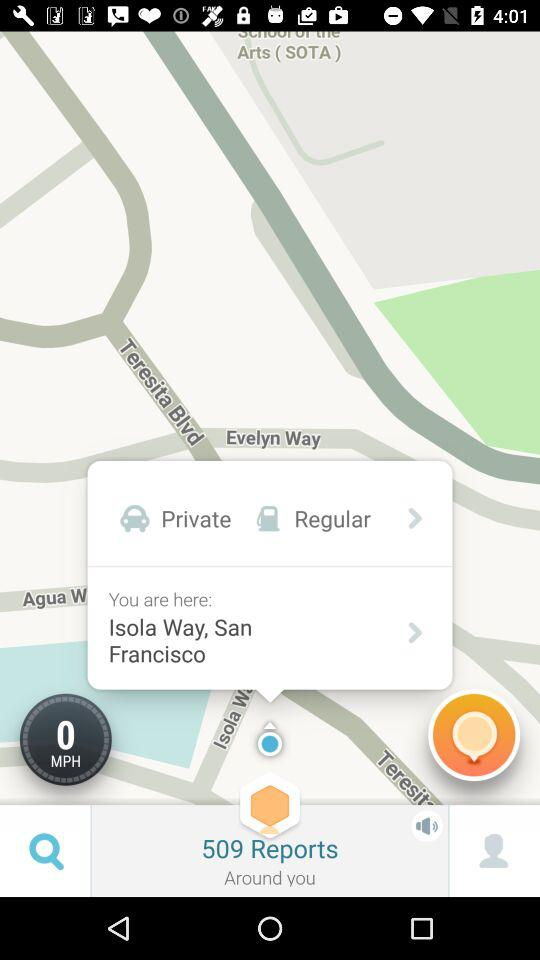How many reports are there?
Answer the question using a single word or phrase. 509 